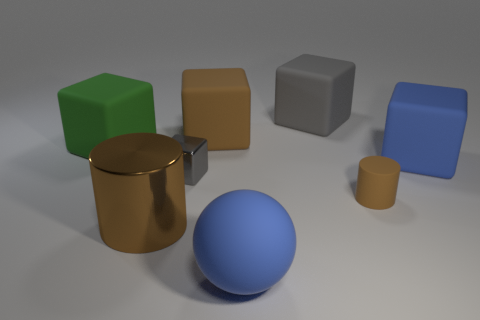Subtract all big gray matte cubes. How many cubes are left? 4 Add 1 large brown blocks. How many objects exist? 9 Subtract all spheres. How many objects are left? 7 Subtract 4 blocks. How many blocks are left? 1 Subtract all brown cubes. How many cubes are left? 4 Add 6 cyan matte objects. How many cyan matte objects exist? 6 Subtract 0 yellow cubes. How many objects are left? 8 Subtract all brown cubes. Subtract all blue balls. How many cubes are left? 4 Subtract all gray balls. How many red cylinders are left? 0 Subtract all tiny matte things. Subtract all big rubber blocks. How many objects are left? 3 